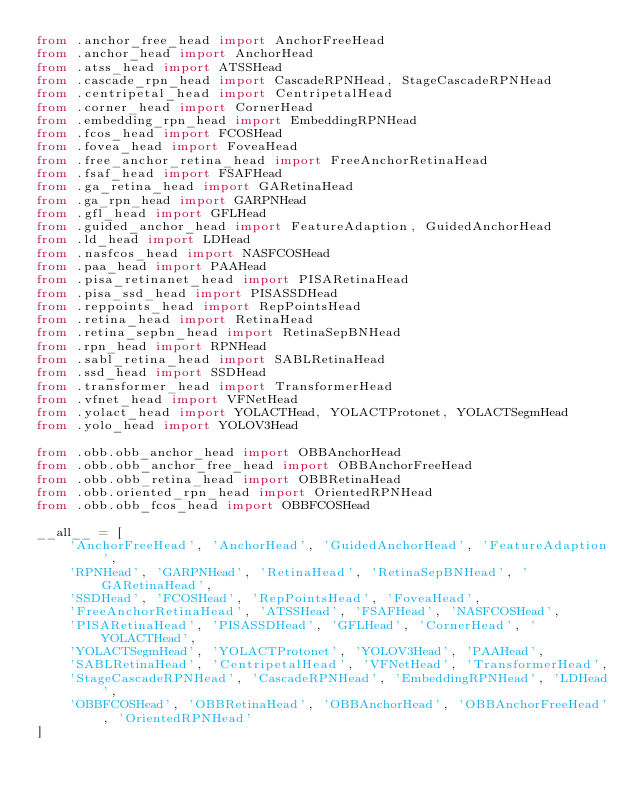<code> <loc_0><loc_0><loc_500><loc_500><_Python_>from .anchor_free_head import AnchorFreeHead
from .anchor_head import AnchorHead
from .atss_head import ATSSHead
from .cascade_rpn_head import CascadeRPNHead, StageCascadeRPNHead
from .centripetal_head import CentripetalHead
from .corner_head import CornerHead
from .embedding_rpn_head import EmbeddingRPNHead
from .fcos_head import FCOSHead
from .fovea_head import FoveaHead
from .free_anchor_retina_head import FreeAnchorRetinaHead
from .fsaf_head import FSAFHead
from .ga_retina_head import GARetinaHead
from .ga_rpn_head import GARPNHead
from .gfl_head import GFLHead
from .guided_anchor_head import FeatureAdaption, GuidedAnchorHead
from .ld_head import LDHead
from .nasfcos_head import NASFCOSHead
from .paa_head import PAAHead
from .pisa_retinanet_head import PISARetinaHead
from .pisa_ssd_head import PISASSDHead
from .reppoints_head import RepPointsHead
from .retina_head import RetinaHead
from .retina_sepbn_head import RetinaSepBNHead
from .rpn_head import RPNHead
from .sabl_retina_head import SABLRetinaHead
from .ssd_head import SSDHead
from .transformer_head import TransformerHead
from .vfnet_head import VFNetHead
from .yolact_head import YOLACTHead, YOLACTProtonet, YOLACTSegmHead
from .yolo_head import YOLOV3Head

from .obb.obb_anchor_head import OBBAnchorHead
from .obb.obb_anchor_free_head import OBBAnchorFreeHead
from .obb.obb_retina_head import OBBRetinaHead
from .obb.oriented_rpn_head import OrientedRPNHead
from .obb.obb_fcos_head import OBBFCOSHead

__all__ = [
    'AnchorFreeHead', 'AnchorHead', 'GuidedAnchorHead', 'FeatureAdaption',
    'RPNHead', 'GARPNHead', 'RetinaHead', 'RetinaSepBNHead', 'GARetinaHead',
    'SSDHead', 'FCOSHead', 'RepPointsHead', 'FoveaHead',
    'FreeAnchorRetinaHead', 'ATSSHead', 'FSAFHead', 'NASFCOSHead',
    'PISARetinaHead', 'PISASSDHead', 'GFLHead', 'CornerHead', 'YOLACTHead',
    'YOLACTSegmHead', 'YOLACTProtonet', 'YOLOV3Head', 'PAAHead',
    'SABLRetinaHead', 'CentripetalHead', 'VFNetHead', 'TransformerHead',
    'StageCascadeRPNHead', 'CascadeRPNHead', 'EmbeddingRPNHead', 'LDHead',
    'OBBFCOSHead', 'OBBRetinaHead', 'OBBAnchorHead', 'OBBAnchorFreeHead', 'OrientedRPNHead'
]
</code> 